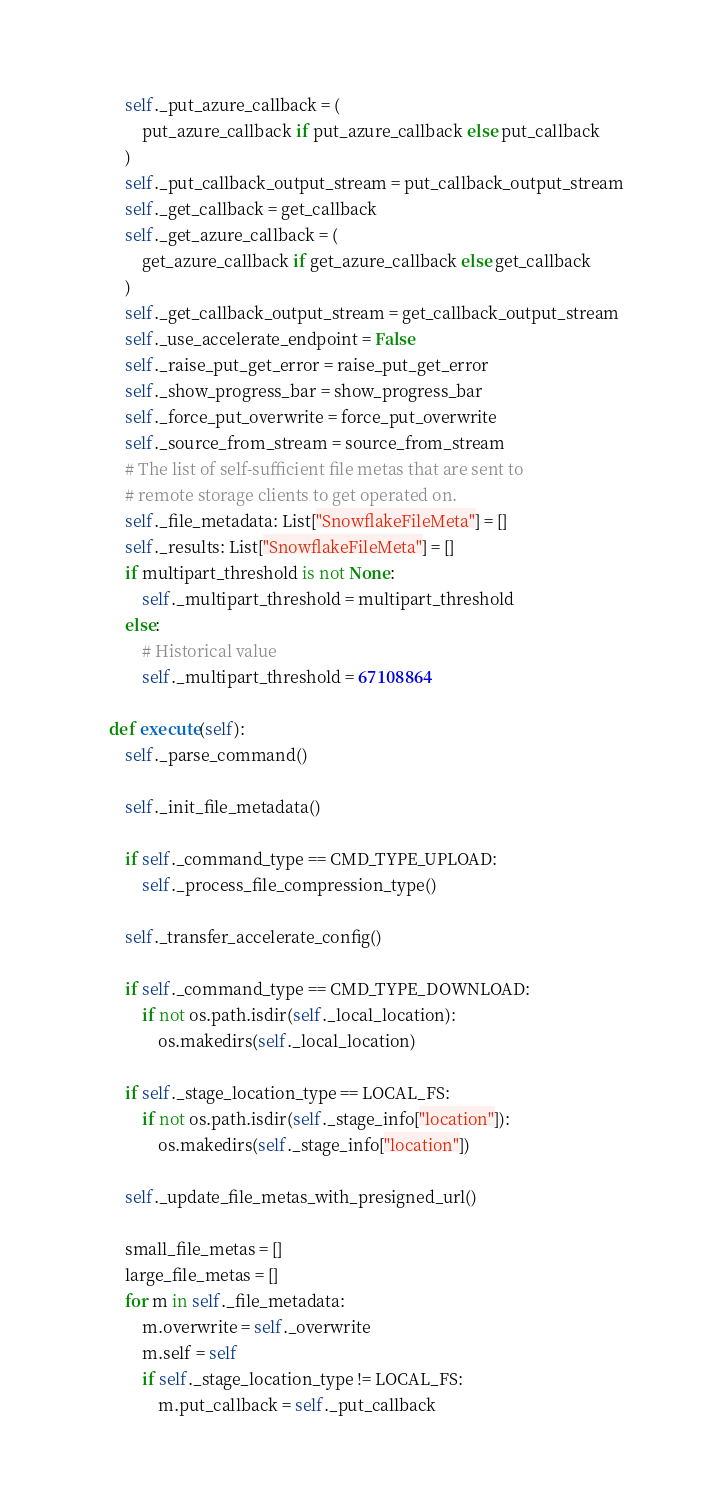<code> <loc_0><loc_0><loc_500><loc_500><_Python_>        self._put_azure_callback = (
            put_azure_callback if put_azure_callback else put_callback
        )
        self._put_callback_output_stream = put_callback_output_stream
        self._get_callback = get_callback
        self._get_azure_callback = (
            get_azure_callback if get_azure_callback else get_callback
        )
        self._get_callback_output_stream = get_callback_output_stream
        self._use_accelerate_endpoint = False
        self._raise_put_get_error = raise_put_get_error
        self._show_progress_bar = show_progress_bar
        self._force_put_overwrite = force_put_overwrite
        self._source_from_stream = source_from_stream
        # The list of self-sufficient file metas that are sent to
        # remote storage clients to get operated on.
        self._file_metadata: List["SnowflakeFileMeta"] = []
        self._results: List["SnowflakeFileMeta"] = []
        if multipart_threshold is not None:
            self._multipart_threshold = multipart_threshold
        else:
            # Historical value
            self._multipart_threshold = 67108864

    def execute(self):
        self._parse_command()

        self._init_file_metadata()

        if self._command_type == CMD_TYPE_UPLOAD:
            self._process_file_compression_type()

        self._transfer_accelerate_config()

        if self._command_type == CMD_TYPE_DOWNLOAD:
            if not os.path.isdir(self._local_location):
                os.makedirs(self._local_location)

        if self._stage_location_type == LOCAL_FS:
            if not os.path.isdir(self._stage_info["location"]):
                os.makedirs(self._stage_info["location"])

        self._update_file_metas_with_presigned_url()

        small_file_metas = []
        large_file_metas = []
        for m in self._file_metadata:
            m.overwrite = self._overwrite
            m.self = self
            if self._stage_location_type != LOCAL_FS:
                m.put_callback = self._put_callback</code> 